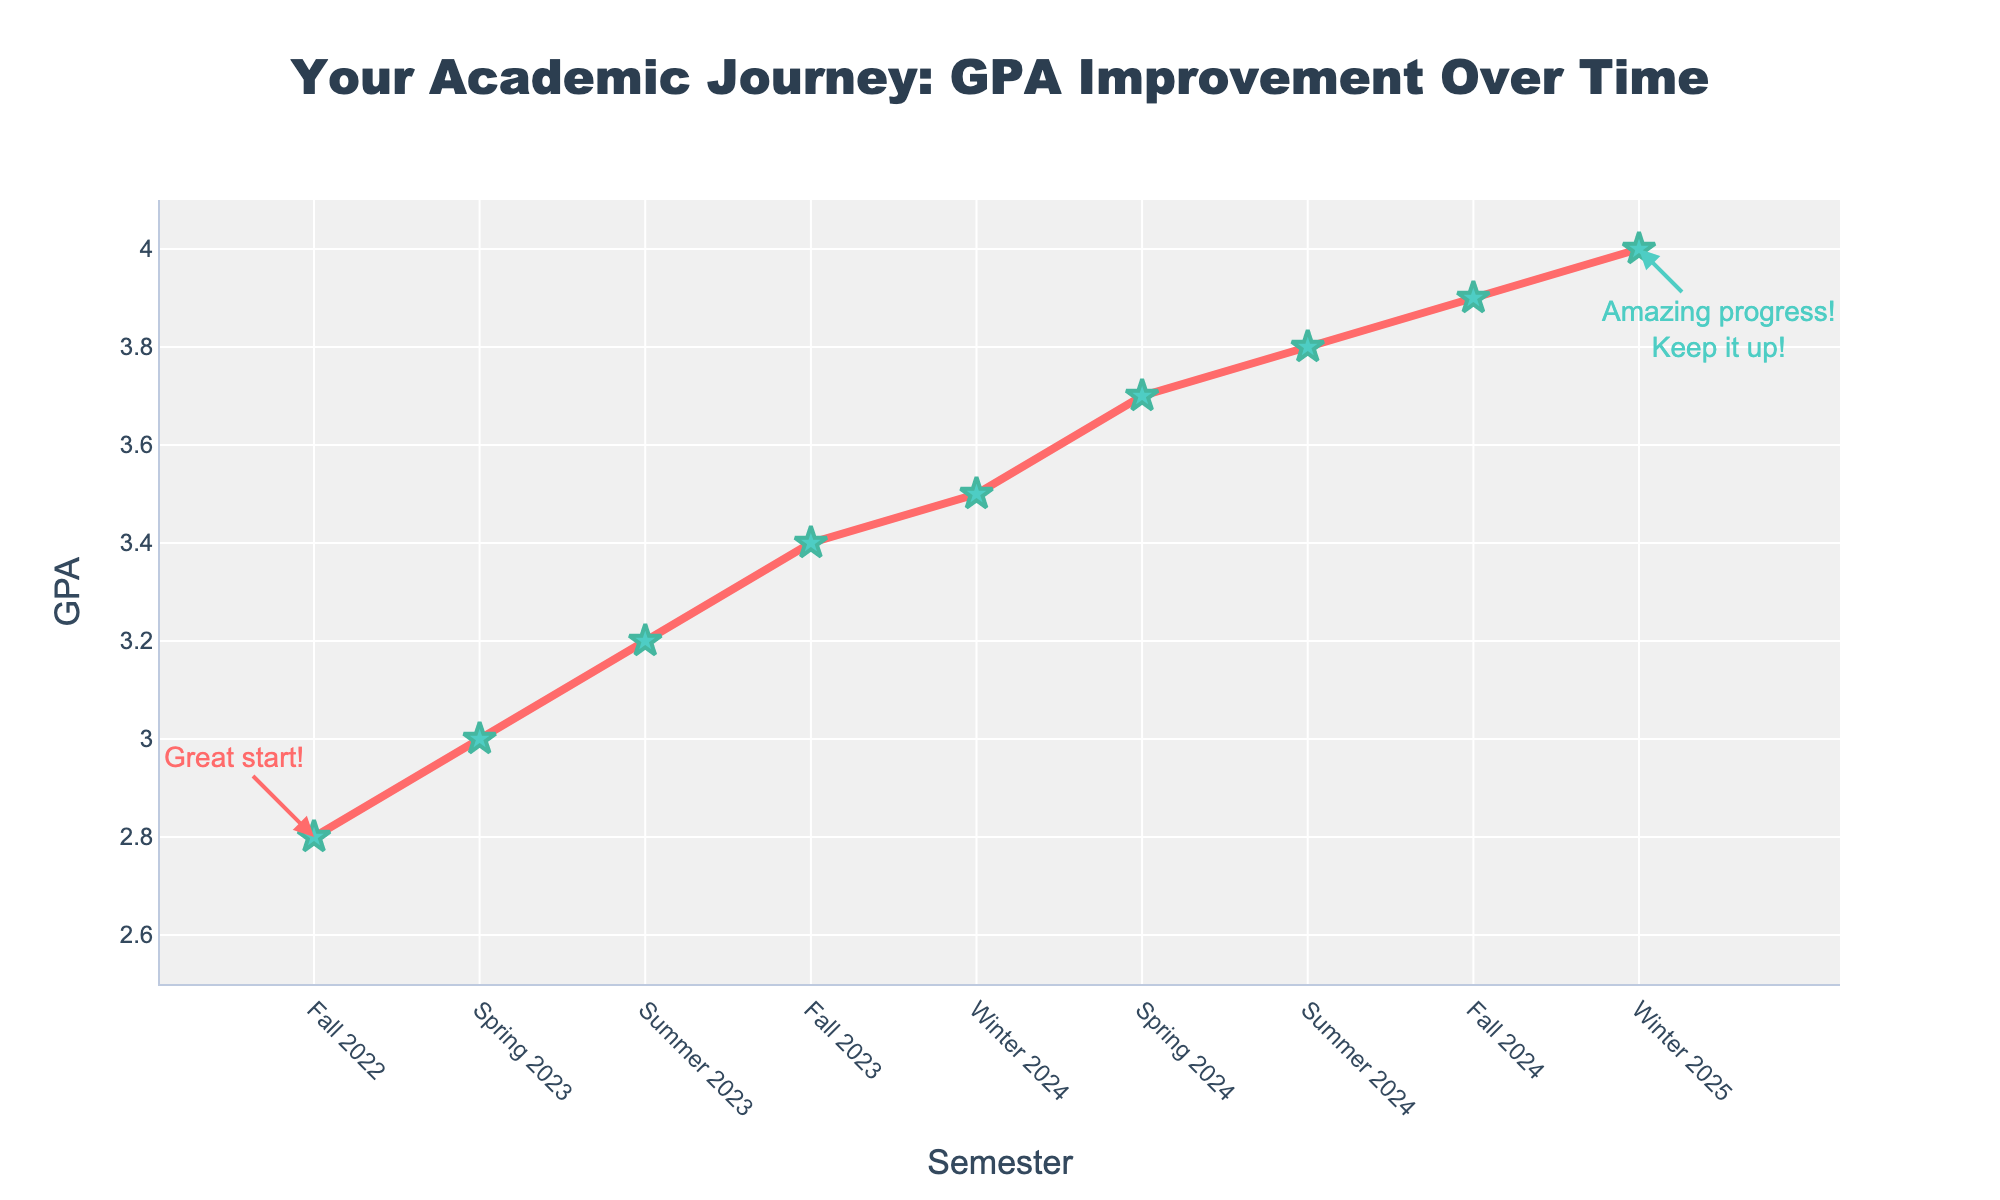What is the general trend in GPA from Fall 2022 to Winter 2025? The GPA increases steadily from 2.8 in Fall 2022 to 4.0 in Winter 2025, indicating consistent academic improvement.
Answer: Increasing Which semester showed the highest GPA improvement compared to the previous semester? Calculate the GPA differences between consecutive semesters and identify the highest: (3.0 - 2.8 = 0.2), (3.2 - 3.0 = 0.2), (3.4 - 3.2 = 0.2), (3.5 - 3.4 = 0.1), (3.7 - 3.5 = 0.2), (3.8 - 3.7 = 0.1), (3.9 - 3.8 = 0.1), (4.0 - 3.9 = 0.1). The highest increase is 0.2, occurring from Fall 2022 to Spring 2023, Spring 2023 to Summer 2023, Fall 2023 to Winter 2024, and Winter 2024 to Spring 2024.
Answer: Fall 2022 to Spring 2023, Spring 2023 to Summer 2023, Fall 2023 to Winter 2024, Winter 2024 to Spring 2024 How much did the GPA increase from Fall 2022 to Winter 2025? Subtract the GPA of Fall 2022 from Winter 2025: 4.0 - 2.8 = 1.2
Answer: 1.2 What is the difference in GPA between Spring 2023 and Fall 2024? Subtract the GPA of Spring 2023 from Fall 2024: 3.9 - 3.0 = 0.9
Answer: 0.9 Based on the chart, during which semester did your GPA first reach 3.5? Identify the semester where GPA is 3.5: Winter 2024
Answer: Winter 2024 Which semesters are marked with annotations? Observing the annotations, they are on Fall 2022 and Winter 2025
Answer: Fall 2022, Winter 2025 By how much did the GPA increase from Fall 2023 to Summer 2024? Subtract the GPA of Fall 2023 from Summer 2024: 3.8 - 3.4 = 0.4
Answer: 0.4 Is the increase in GPA between Summer 2023 and Fall 2023 greater or smaller than the increase between Spring 2024 and Summer 2024? Calculate the GPA increases: (Fall 2023 - Summer 2023 = 3.4 - 3.2 = 0.2) and (Summer 2024 - Spring 2024 = 3.8 - 3.7 = 0.1). The Fall 2023 increase is greater.
Answer: Greater What is the average GPA over all the provided semesters? Sum all GPAs and divide by the number of semesters: (2.8 + 3.0 + 3.2 + 3.4 + 3.5 + 3.7 + 3.8 + 3.9 + 4.0) / 9 = 3.477
Answer: 3.477 What is the difference in GPA between the highest and lowest semesters? Identify highest GPA (Winter 2025, 4.0) and lowest GPA (Fall 2022, 2.8), then subtract: 4.0 - 2.8 = 1.2
Answer: 1.2 